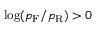<formula> <loc_0><loc_0><loc_500><loc_500>\log ( p _ { F } / p _ { R } ) > 0</formula> 